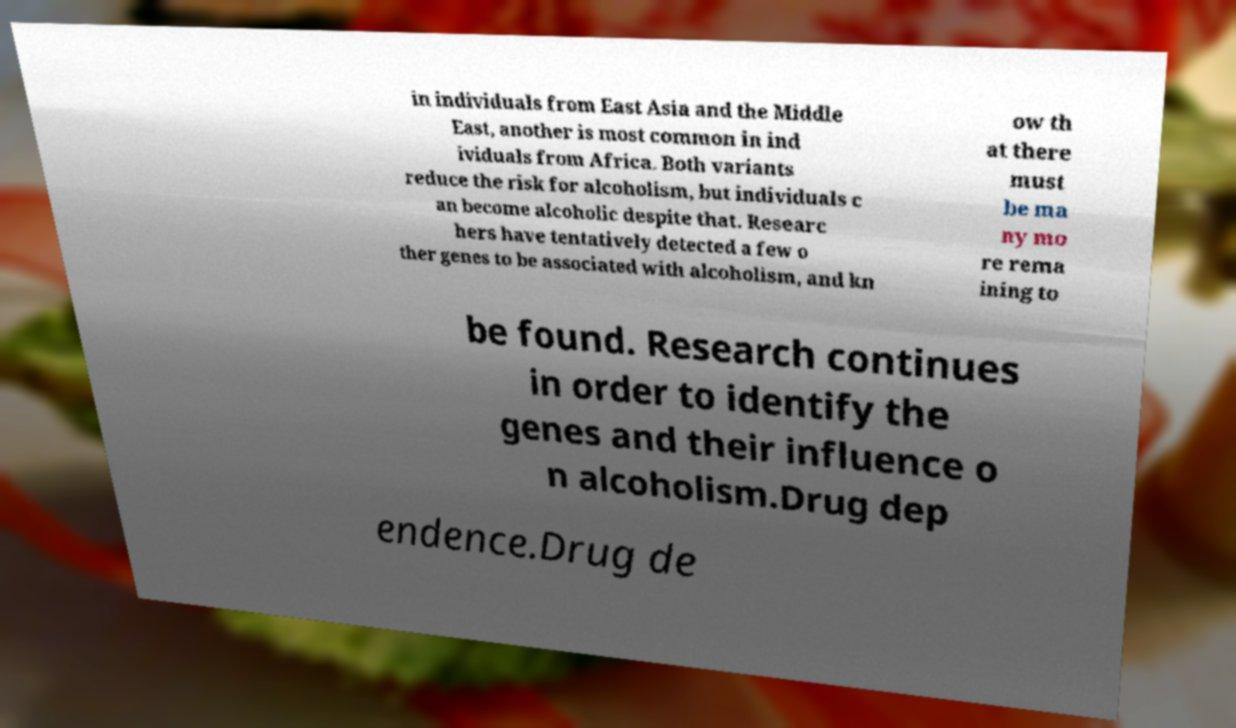Please read and relay the text visible in this image. What does it say? in individuals from East Asia and the Middle East, another is most common in ind ividuals from Africa. Both variants reduce the risk for alcoholism, but individuals c an become alcoholic despite that. Researc hers have tentatively detected a few o ther genes to be associated with alcoholism, and kn ow th at there must be ma ny mo re rema ining to be found. Research continues in order to identify the genes and their influence o n alcoholism.Drug dep endence.Drug de 